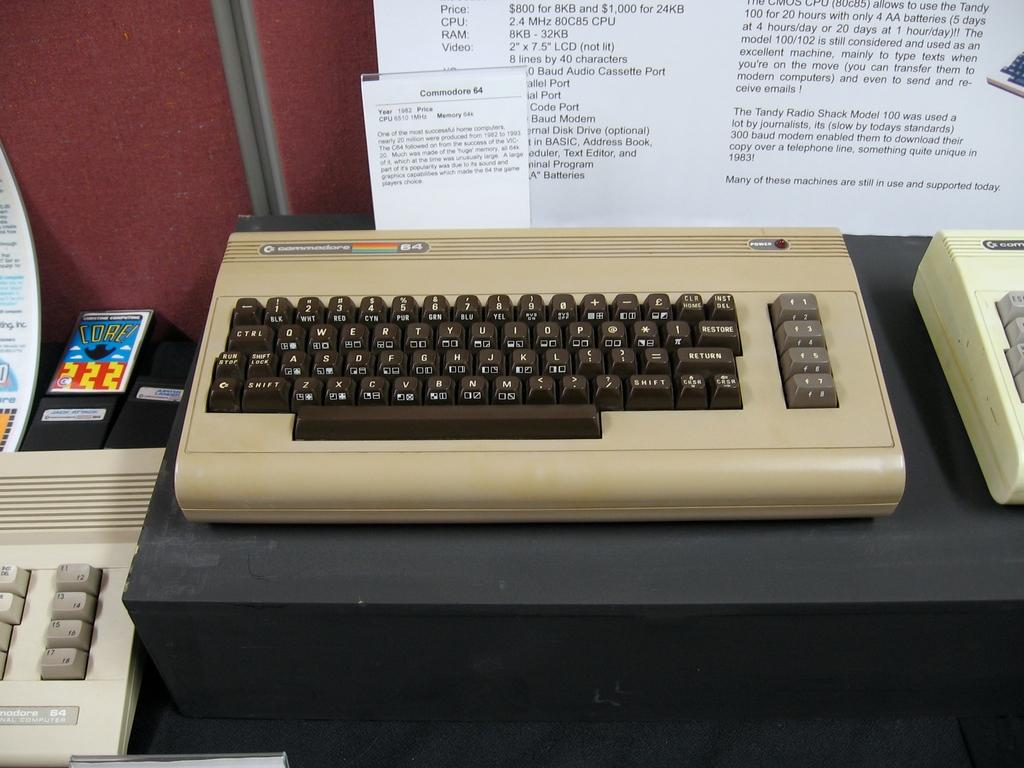Provide a one-sentence caption for the provided image. An old computer keyboard next to a bunch of other old computer keyboards. 